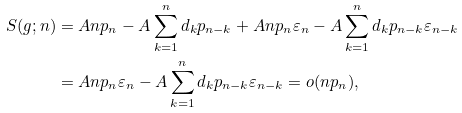Convert formula to latex. <formula><loc_0><loc_0><loc_500><loc_500>S ( g ; n ) & = A n p _ { n } - A \sum _ { k = 1 } ^ { n } d _ { k } p _ { n - k } + A n p _ { n } \varepsilon _ { n } - A \sum _ { k = 1 } ^ { n } d _ { k } p _ { n - k } \varepsilon _ { n - k } \\ & = A n p _ { n } \varepsilon _ { n } - A \sum _ { k = 1 } ^ { n } d _ { k } p _ { n - k } \varepsilon _ { n - k } = o ( n p _ { n } ) ,</formula> 